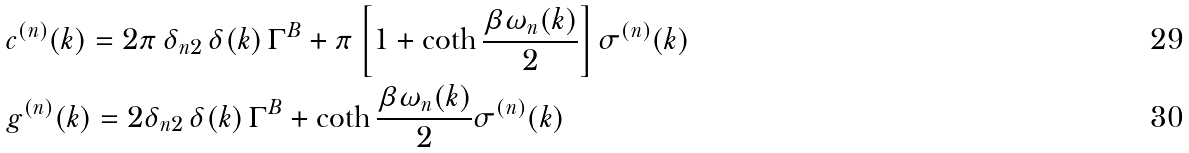<formula> <loc_0><loc_0><loc_500><loc_500>& c ^ { ( n ) } ( k ) = 2 \pi \, \delta _ { n 2 } \, \delta ( k ) \, \Gamma ^ { B } + \pi \left [ 1 + \coth \frac { \beta \omega _ { n } ( k ) } { 2 } \right ] \sigma ^ { ( n ) } ( k ) \\ & g ^ { ( n ) } ( k ) = 2 \delta _ { n 2 } \, \delta ( k ) \, \Gamma ^ { B } + \coth \frac { \beta \omega _ { n } ( k ) } { 2 } \sigma ^ { ( n ) } ( k )</formula> 